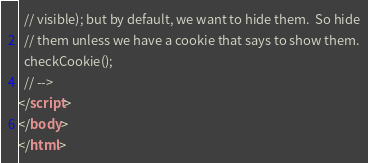Convert code to text. <code><loc_0><loc_0><loc_500><loc_500><_HTML_>  // visible); but by default, we want to hide them.  So hide
  // them unless we have a cookie that says to show them.
  checkCookie();
  // -->
</script>
</body>
</html>
</code> 